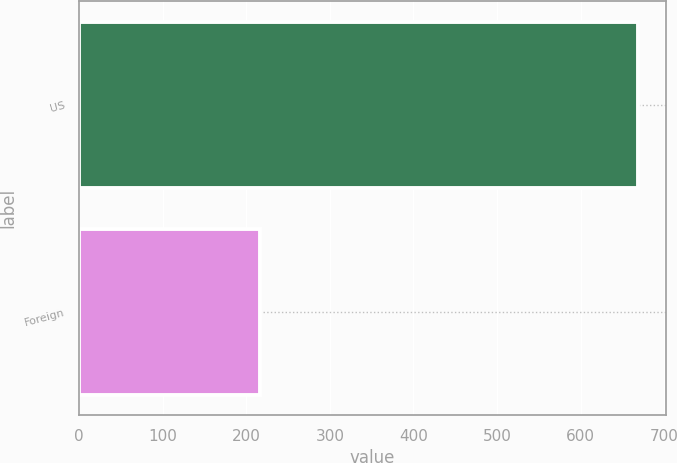<chart> <loc_0><loc_0><loc_500><loc_500><bar_chart><fcel>US<fcel>Foreign<nl><fcel>669<fcel>217<nl></chart> 